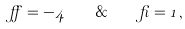<formula> <loc_0><loc_0><loc_500><loc_500>\alpha = - 4 \quad \& \quad \beta = 1 \, ,</formula> 